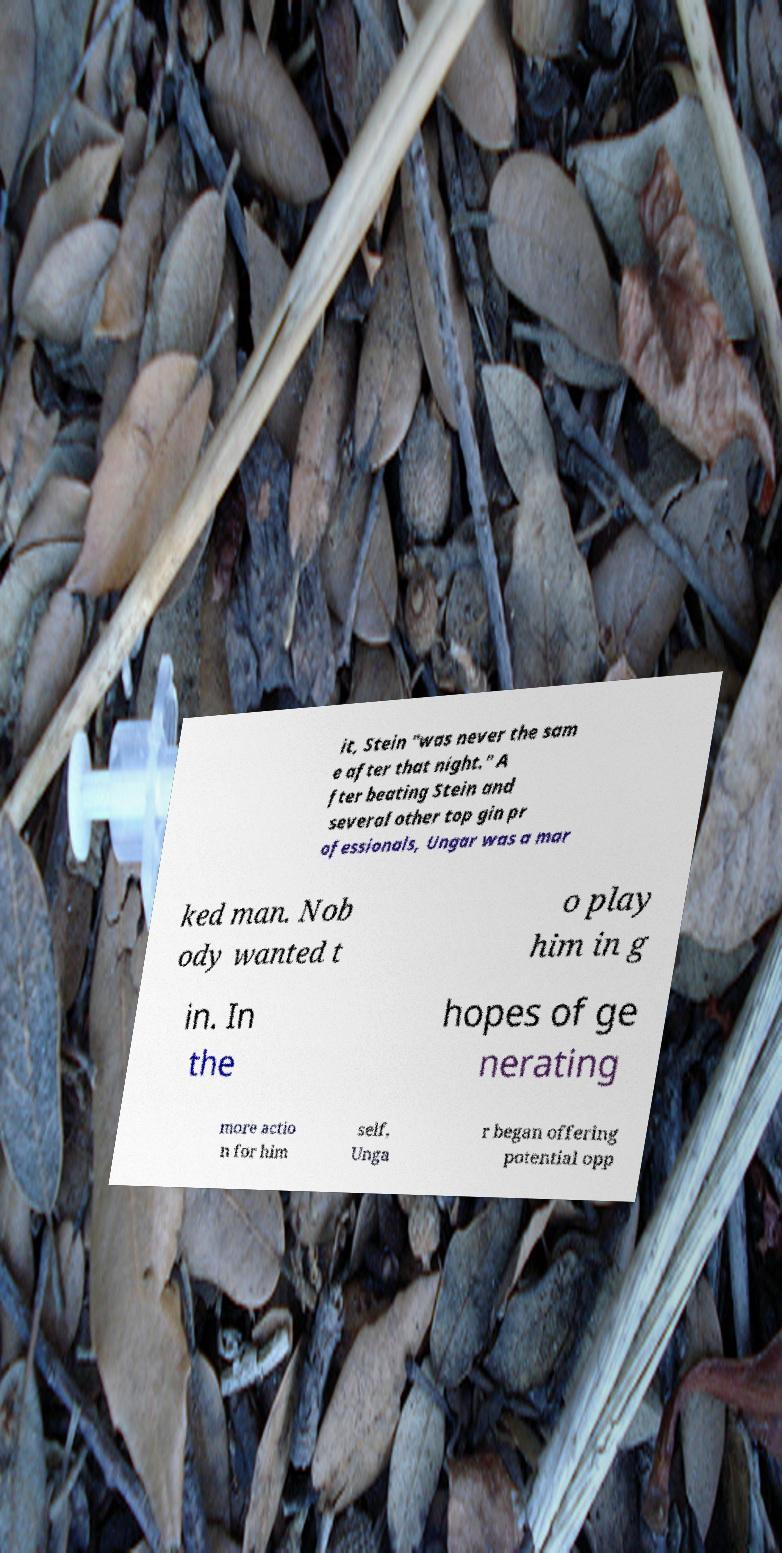What messages or text are displayed in this image? I need them in a readable, typed format. it, Stein "was never the sam e after that night." A fter beating Stein and several other top gin pr ofessionals, Ungar was a mar ked man. Nob ody wanted t o play him in g in. In the hopes of ge nerating more actio n for him self, Unga r began offering potential opp 